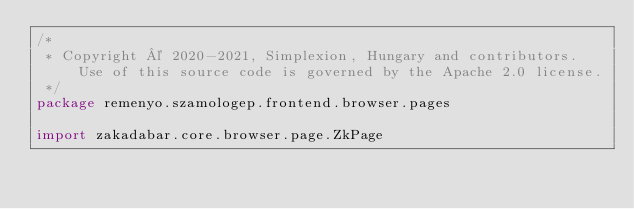<code> <loc_0><loc_0><loc_500><loc_500><_Kotlin_>/*
 * Copyright © 2020-2021, Simplexion, Hungary and contributors. Use of this source code is governed by the Apache 2.0 license.
 */
package remenyo.szamologep.frontend.browser.pages

import zakadabar.core.browser.page.ZkPage</code> 